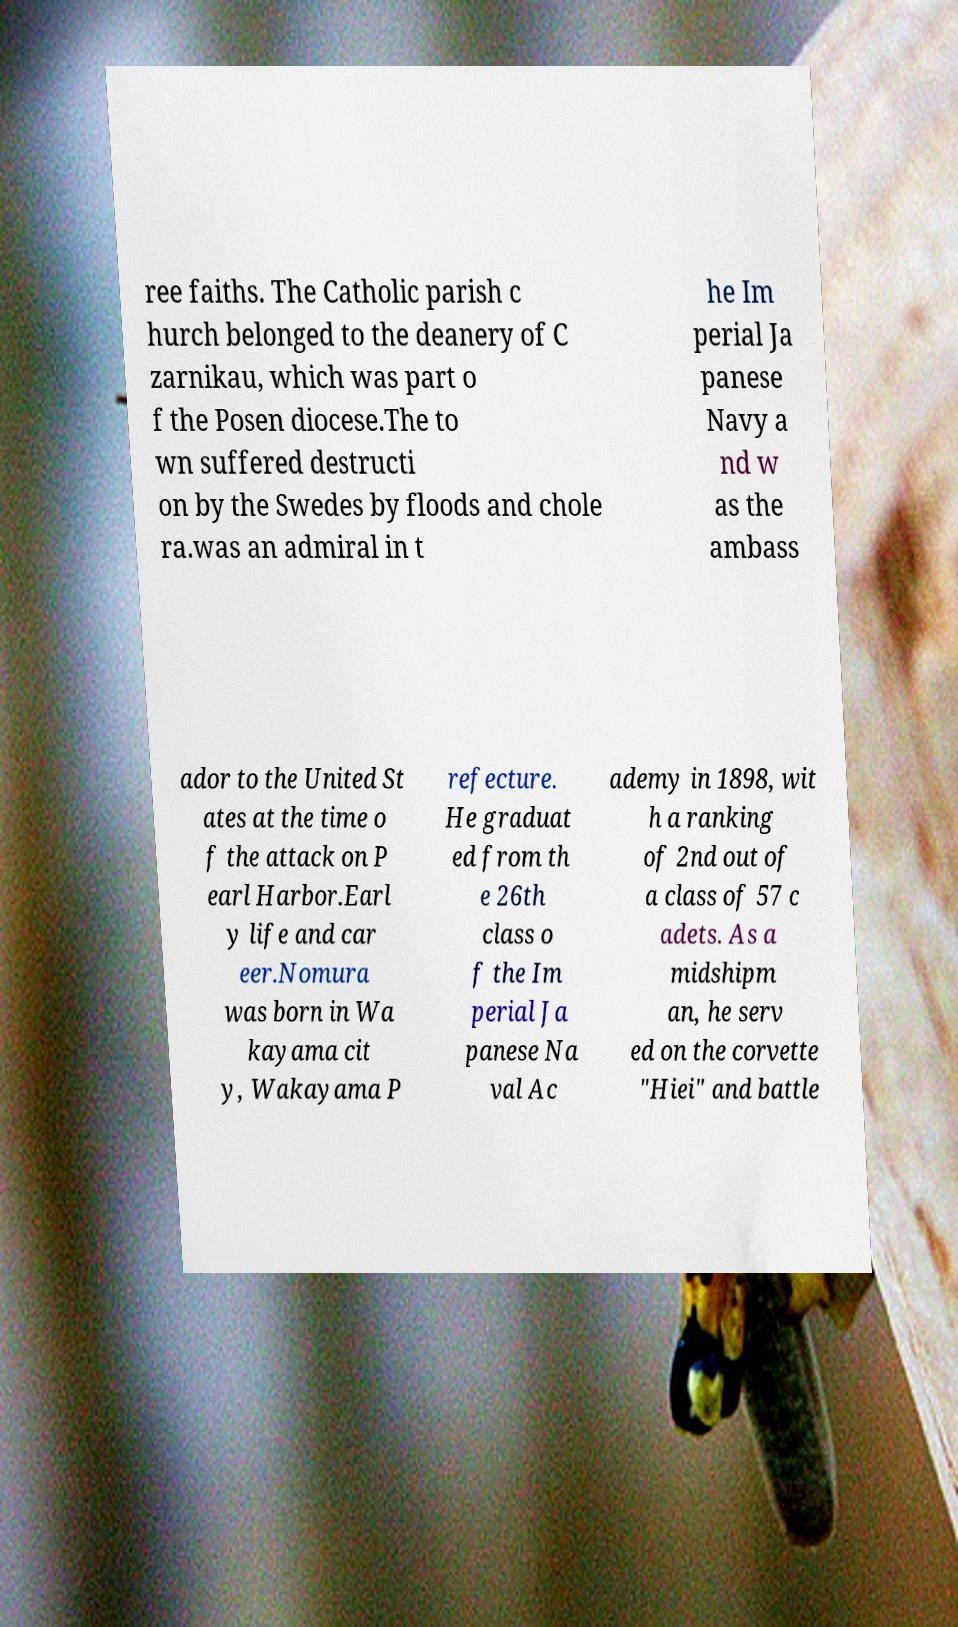Can you read and provide the text displayed in the image?This photo seems to have some interesting text. Can you extract and type it out for me? ree faiths. The Catholic parish c hurch belonged to the deanery of C zarnikau, which was part o f the Posen diocese.The to wn suffered destructi on by the Swedes by floods and chole ra.was an admiral in t he Im perial Ja panese Navy a nd w as the ambass ador to the United St ates at the time o f the attack on P earl Harbor.Earl y life and car eer.Nomura was born in Wa kayama cit y, Wakayama P refecture. He graduat ed from th e 26th class o f the Im perial Ja panese Na val Ac ademy in 1898, wit h a ranking of 2nd out of a class of 57 c adets. As a midshipm an, he serv ed on the corvette "Hiei" and battle 